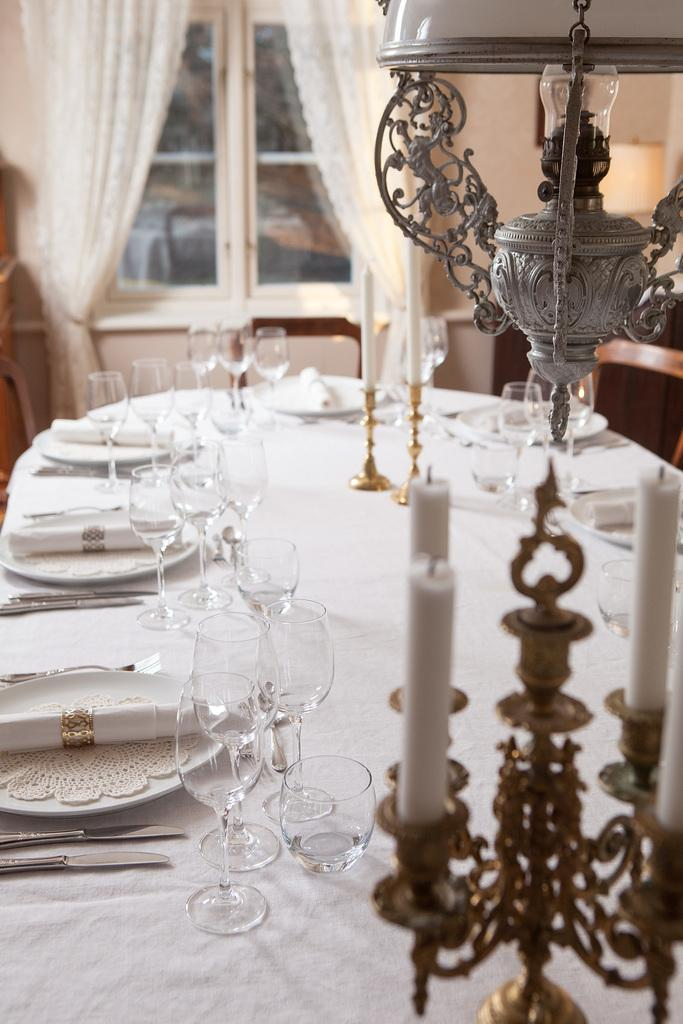What type of tableware can be seen on the table in the image? There are glasses, plates, forks, and a knife on the table in the image. What additional items are present on the table? There are candles and candle stands on the table. What can be seen in the background of the image? There are curtains and glass windows in the background. What decision can be seen being made by the brain in the image? There is no brain present in the image, and therefore no decision-making can be observed. 